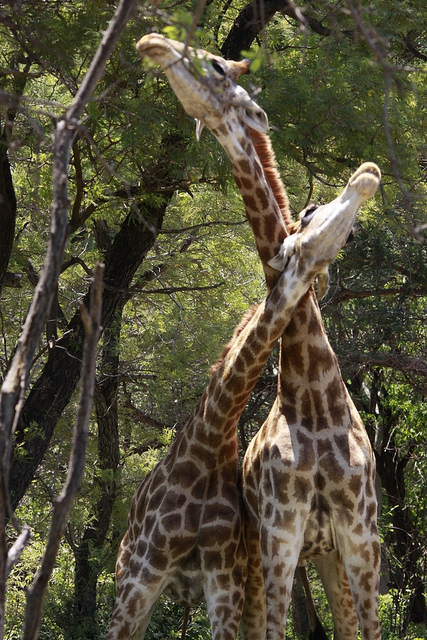How many giraffes are there? There are two giraffes present in the image, standing amidst trees and stretching their long necks upwards, possibly reaching for leaves to feed on, creating a picturesque scene of these majestic animals in their natural habitat. 